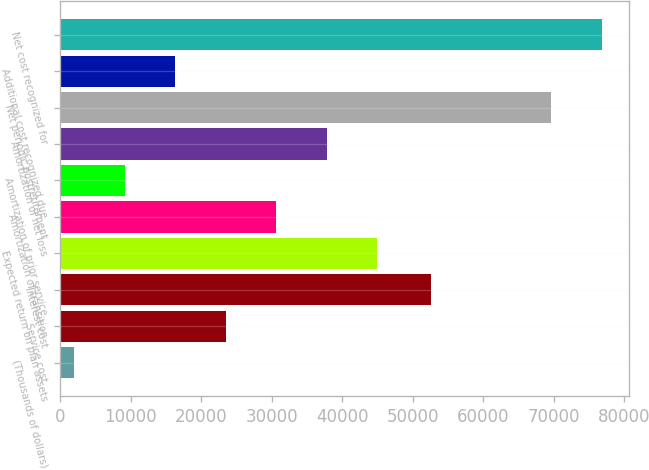Convert chart to OTSL. <chart><loc_0><loc_0><loc_500><loc_500><bar_chart><fcel>(Thousands of dollars)<fcel>Service cost<fcel>Interest cost<fcel>Expected return on plan assets<fcel>Amortization of transition<fcel>Amortization of prior service<fcel>Amortization of net loss<fcel>Net periodic postretirement<fcel>Additional cost recognized due<fcel>Net cost recognized for<nl><fcel>2004<fcel>23476.5<fcel>52604<fcel>44949<fcel>30634<fcel>9161.5<fcel>37791.5<fcel>69688<fcel>16319<fcel>76845.5<nl></chart> 